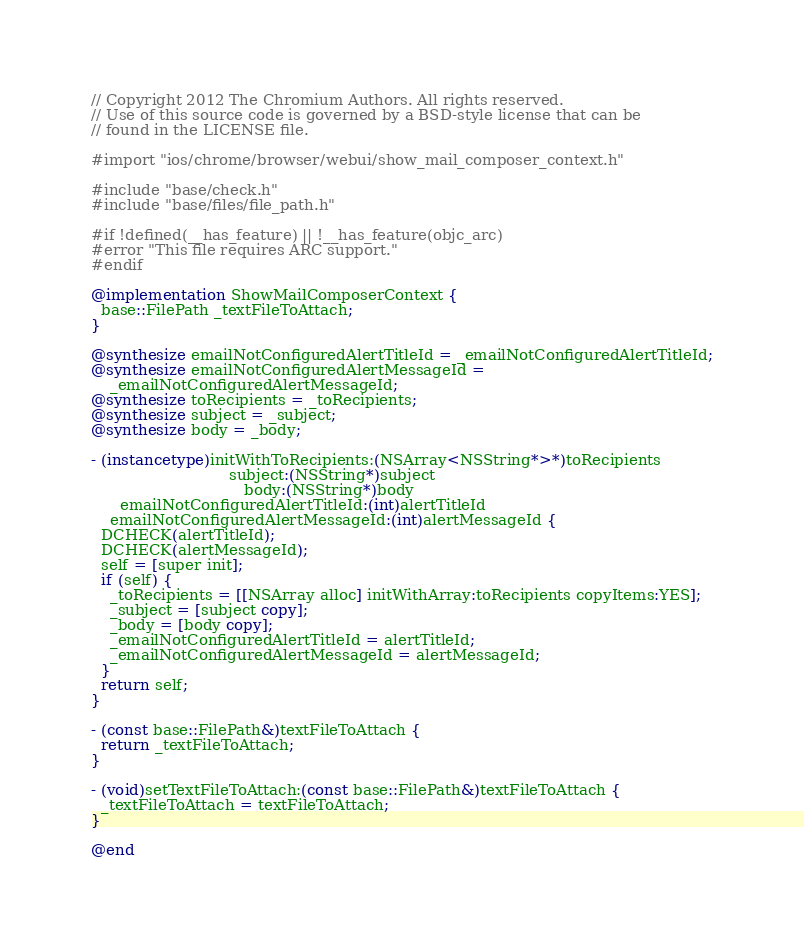<code> <loc_0><loc_0><loc_500><loc_500><_ObjectiveC_>// Copyright 2012 The Chromium Authors. All rights reserved.
// Use of this source code is governed by a BSD-style license that can be
// found in the LICENSE file.

#import "ios/chrome/browser/webui/show_mail_composer_context.h"

#include "base/check.h"
#include "base/files/file_path.h"

#if !defined(__has_feature) || !__has_feature(objc_arc)
#error "This file requires ARC support."
#endif

@implementation ShowMailComposerContext {
  base::FilePath _textFileToAttach;
}

@synthesize emailNotConfiguredAlertTitleId = _emailNotConfiguredAlertTitleId;
@synthesize emailNotConfiguredAlertMessageId =
    _emailNotConfiguredAlertMessageId;
@synthesize toRecipients = _toRecipients;
@synthesize subject = _subject;
@synthesize body = _body;

- (instancetype)initWithToRecipients:(NSArray<NSString*>*)toRecipients
                             subject:(NSString*)subject
                                body:(NSString*)body
      emailNotConfiguredAlertTitleId:(int)alertTitleId
    emailNotConfiguredAlertMessageId:(int)alertMessageId {
  DCHECK(alertTitleId);
  DCHECK(alertMessageId);
  self = [super init];
  if (self) {
    _toRecipients = [[NSArray alloc] initWithArray:toRecipients copyItems:YES];
    _subject = [subject copy];
    _body = [body copy];
    _emailNotConfiguredAlertTitleId = alertTitleId;
    _emailNotConfiguredAlertMessageId = alertMessageId;
  }
  return self;
}

- (const base::FilePath&)textFileToAttach {
  return _textFileToAttach;
}

- (void)setTextFileToAttach:(const base::FilePath&)textFileToAttach {
  _textFileToAttach = textFileToAttach;
}

@end
</code> 